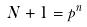<formula> <loc_0><loc_0><loc_500><loc_500>N + 1 = p ^ { n }</formula> 